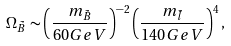Convert formula to latex. <formula><loc_0><loc_0><loc_500><loc_500>\Omega _ { \tilde { B } } \sim \left ( \frac { m _ { \tilde { B } } } { 6 0 G e V } \right ) ^ { - 2 } \left ( \frac { m _ { \tilde { l } } } { 1 4 0 G e V } \right ) ^ { 4 } ,</formula> 